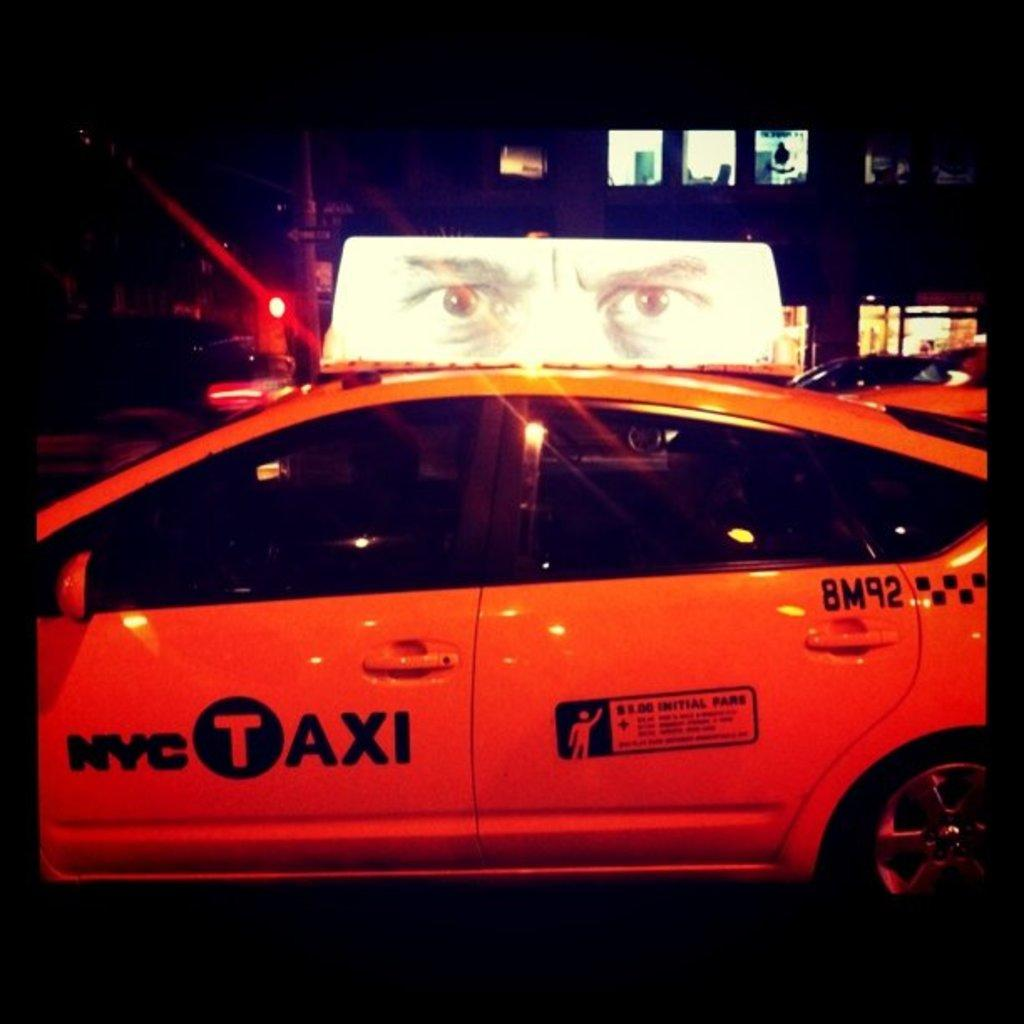Provide a one-sentence caption for the provided image. A New York City taxi bears the number 8M92 on its rear door. 